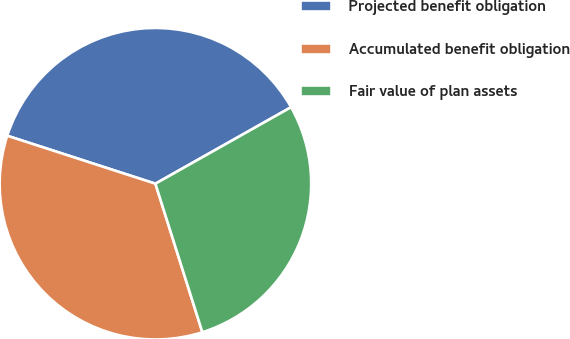<chart> <loc_0><loc_0><loc_500><loc_500><pie_chart><fcel>Projected benefit obligation<fcel>Accumulated benefit obligation<fcel>Fair value of plan assets<nl><fcel>36.85%<fcel>34.86%<fcel>28.3%<nl></chart> 